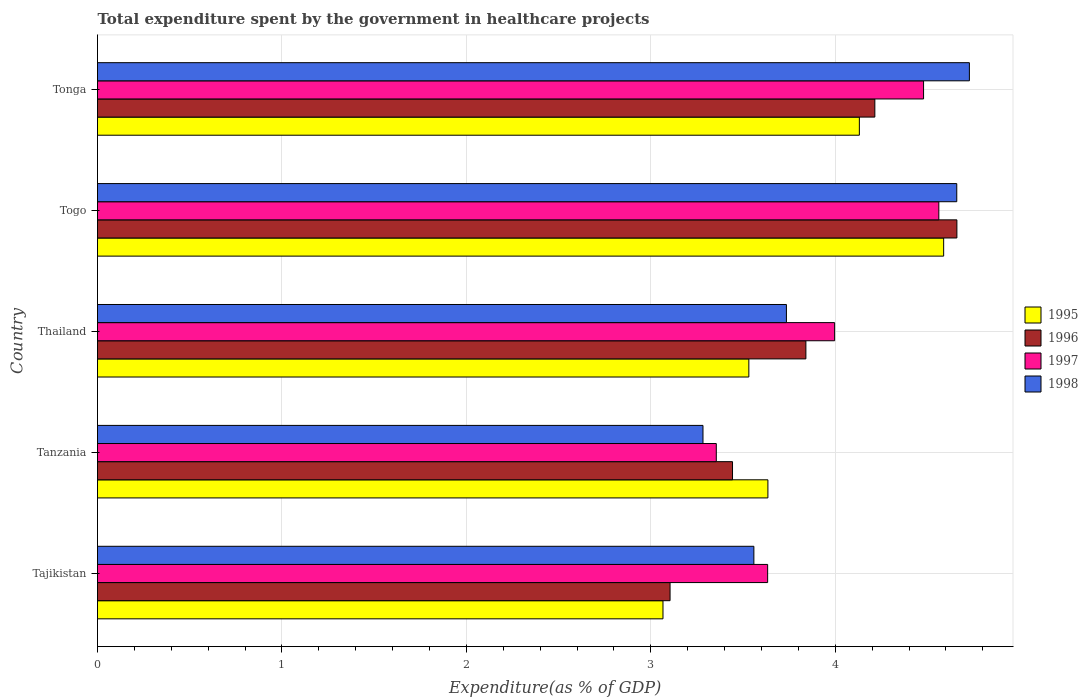How many different coloured bars are there?
Ensure brevity in your answer.  4. Are the number of bars per tick equal to the number of legend labels?
Provide a short and direct response. Yes. How many bars are there on the 3rd tick from the bottom?
Your answer should be compact. 4. What is the label of the 2nd group of bars from the top?
Offer a terse response. Togo. In how many cases, is the number of bars for a given country not equal to the number of legend labels?
Provide a succinct answer. 0. What is the total expenditure spent by the government in healthcare projects in 1998 in Thailand?
Ensure brevity in your answer.  3.74. Across all countries, what is the maximum total expenditure spent by the government in healthcare projects in 1995?
Keep it short and to the point. 4.59. Across all countries, what is the minimum total expenditure spent by the government in healthcare projects in 1995?
Provide a short and direct response. 3.07. In which country was the total expenditure spent by the government in healthcare projects in 1998 maximum?
Ensure brevity in your answer.  Tonga. In which country was the total expenditure spent by the government in healthcare projects in 1998 minimum?
Your answer should be compact. Tanzania. What is the total total expenditure spent by the government in healthcare projects in 1998 in the graph?
Make the answer very short. 19.96. What is the difference between the total expenditure spent by the government in healthcare projects in 1995 in Togo and that in Tonga?
Your response must be concise. 0.46. What is the difference between the total expenditure spent by the government in healthcare projects in 1996 in Tanzania and the total expenditure spent by the government in healthcare projects in 1997 in Tonga?
Provide a short and direct response. -1.04. What is the average total expenditure spent by the government in healthcare projects in 1997 per country?
Offer a very short reply. 4.01. What is the difference between the total expenditure spent by the government in healthcare projects in 1997 and total expenditure spent by the government in healthcare projects in 1998 in Tonga?
Your response must be concise. -0.25. What is the ratio of the total expenditure spent by the government in healthcare projects in 1995 in Tajikistan to that in Tonga?
Your answer should be compact. 0.74. Is the difference between the total expenditure spent by the government in healthcare projects in 1997 in Tanzania and Thailand greater than the difference between the total expenditure spent by the government in healthcare projects in 1998 in Tanzania and Thailand?
Provide a succinct answer. No. What is the difference between the highest and the second highest total expenditure spent by the government in healthcare projects in 1998?
Your answer should be very brief. 0.07. What is the difference between the highest and the lowest total expenditure spent by the government in healthcare projects in 1997?
Your response must be concise. 1.21. What does the 1st bar from the top in Tanzania represents?
Offer a very short reply. 1998. Are all the bars in the graph horizontal?
Your response must be concise. Yes. How many countries are there in the graph?
Offer a terse response. 5. What is the difference between two consecutive major ticks on the X-axis?
Give a very brief answer. 1. Are the values on the major ticks of X-axis written in scientific E-notation?
Provide a short and direct response. No. Does the graph contain any zero values?
Your response must be concise. No. Does the graph contain grids?
Your answer should be very brief. Yes. How are the legend labels stacked?
Your answer should be very brief. Vertical. What is the title of the graph?
Offer a terse response. Total expenditure spent by the government in healthcare projects. Does "1991" appear as one of the legend labels in the graph?
Provide a short and direct response. No. What is the label or title of the X-axis?
Keep it short and to the point. Expenditure(as % of GDP). What is the label or title of the Y-axis?
Your answer should be compact. Country. What is the Expenditure(as % of GDP) in 1995 in Tajikistan?
Offer a terse response. 3.07. What is the Expenditure(as % of GDP) in 1996 in Tajikistan?
Ensure brevity in your answer.  3.1. What is the Expenditure(as % of GDP) of 1997 in Tajikistan?
Your response must be concise. 3.63. What is the Expenditure(as % of GDP) in 1998 in Tajikistan?
Offer a terse response. 3.56. What is the Expenditure(as % of GDP) of 1995 in Tanzania?
Make the answer very short. 3.63. What is the Expenditure(as % of GDP) of 1996 in Tanzania?
Offer a terse response. 3.44. What is the Expenditure(as % of GDP) in 1997 in Tanzania?
Offer a terse response. 3.36. What is the Expenditure(as % of GDP) in 1998 in Tanzania?
Ensure brevity in your answer.  3.28. What is the Expenditure(as % of GDP) in 1995 in Thailand?
Offer a terse response. 3.53. What is the Expenditure(as % of GDP) in 1996 in Thailand?
Give a very brief answer. 3.84. What is the Expenditure(as % of GDP) of 1997 in Thailand?
Ensure brevity in your answer.  4. What is the Expenditure(as % of GDP) of 1998 in Thailand?
Give a very brief answer. 3.74. What is the Expenditure(as % of GDP) in 1995 in Togo?
Your response must be concise. 4.59. What is the Expenditure(as % of GDP) in 1996 in Togo?
Offer a terse response. 4.66. What is the Expenditure(as % of GDP) of 1997 in Togo?
Provide a succinct answer. 4.56. What is the Expenditure(as % of GDP) in 1998 in Togo?
Make the answer very short. 4.66. What is the Expenditure(as % of GDP) in 1995 in Tonga?
Make the answer very short. 4.13. What is the Expenditure(as % of GDP) of 1996 in Tonga?
Your answer should be compact. 4.21. What is the Expenditure(as % of GDP) in 1997 in Tonga?
Keep it short and to the point. 4.48. What is the Expenditure(as % of GDP) of 1998 in Tonga?
Offer a terse response. 4.73. Across all countries, what is the maximum Expenditure(as % of GDP) of 1995?
Give a very brief answer. 4.59. Across all countries, what is the maximum Expenditure(as % of GDP) in 1996?
Ensure brevity in your answer.  4.66. Across all countries, what is the maximum Expenditure(as % of GDP) in 1997?
Ensure brevity in your answer.  4.56. Across all countries, what is the maximum Expenditure(as % of GDP) in 1998?
Your response must be concise. 4.73. Across all countries, what is the minimum Expenditure(as % of GDP) in 1995?
Make the answer very short. 3.07. Across all countries, what is the minimum Expenditure(as % of GDP) in 1996?
Make the answer very short. 3.1. Across all countries, what is the minimum Expenditure(as % of GDP) in 1997?
Offer a very short reply. 3.36. Across all countries, what is the minimum Expenditure(as % of GDP) in 1998?
Keep it short and to the point. 3.28. What is the total Expenditure(as % of GDP) in 1995 in the graph?
Offer a terse response. 18.95. What is the total Expenditure(as % of GDP) of 1996 in the graph?
Your response must be concise. 19.26. What is the total Expenditure(as % of GDP) in 1997 in the graph?
Your response must be concise. 20.03. What is the total Expenditure(as % of GDP) in 1998 in the graph?
Ensure brevity in your answer.  19.96. What is the difference between the Expenditure(as % of GDP) of 1995 in Tajikistan and that in Tanzania?
Offer a very short reply. -0.57. What is the difference between the Expenditure(as % of GDP) of 1996 in Tajikistan and that in Tanzania?
Your answer should be compact. -0.34. What is the difference between the Expenditure(as % of GDP) of 1997 in Tajikistan and that in Tanzania?
Provide a short and direct response. 0.28. What is the difference between the Expenditure(as % of GDP) of 1998 in Tajikistan and that in Tanzania?
Offer a very short reply. 0.28. What is the difference between the Expenditure(as % of GDP) of 1995 in Tajikistan and that in Thailand?
Ensure brevity in your answer.  -0.47. What is the difference between the Expenditure(as % of GDP) in 1996 in Tajikistan and that in Thailand?
Provide a short and direct response. -0.74. What is the difference between the Expenditure(as % of GDP) in 1997 in Tajikistan and that in Thailand?
Your answer should be compact. -0.36. What is the difference between the Expenditure(as % of GDP) in 1998 in Tajikistan and that in Thailand?
Offer a terse response. -0.18. What is the difference between the Expenditure(as % of GDP) in 1995 in Tajikistan and that in Togo?
Offer a terse response. -1.52. What is the difference between the Expenditure(as % of GDP) in 1996 in Tajikistan and that in Togo?
Provide a short and direct response. -1.56. What is the difference between the Expenditure(as % of GDP) of 1997 in Tajikistan and that in Togo?
Offer a very short reply. -0.93. What is the difference between the Expenditure(as % of GDP) of 1998 in Tajikistan and that in Togo?
Provide a short and direct response. -1.1. What is the difference between the Expenditure(as % of GDP) of 1995 in Tajikistan and that in Tonga?
Your answer should be compact. -1.06. What is the difference between the Expenditure(as % of GDP) in 1996 in Tajikistan and that in Tonga?
Give a very brief answer. -1.11. What is the difference between the Expenditure(as % of GDP) in 1997 in Tajikistan and that in Tonga?
Keep it short and to the point. -0.85. What is the difference between the Expenditure(as % of GDP) of 1998 in Tajikistan and that in Tonga?
Keep it short and to the point. -1.17. What is the difference between the Expenditure(as % of GDP) of 1995 in Tanzania and that in Thailand?
Ensure brevity in your answer.  0.1. What is the difference between the Expenditure(as % of GDP) of 1996 in Tanzania and that in Thailand?
Your answer should be very brief. -0.4. What is the difference between the Expenditure(as % of GDP) in 1997 in Tanzania and that in Thailand?
Make the answer very short. -0.64. What is the difference between the Expenditure(as % of GDP) of 1998 in Tanzania and that in Thailand?
Provide a short and direct response. -0.45. What is the difference between the Expenditure(as % of GDP) in 1995 in Tanzania and that in Togo?
Provide a short and direct response. -0.95. What is the difference between the Expenditure(as % of GDP) of 1996 in Tanzania and that in Togo?
Your response must be concise. -1.22. What is the difference between the Expenditure(as % of GDP) of 1997 in Tanzania and that in Togo?
Offer a terse response. -1.21. What is the difference between the Expenditure(as % of GDP) of 1998 in Tanzania and that in Togo?
Your answer should be very brief. -1.38. What is the difference between the Expenditure(as % of GDP) of 1995 in Tanzania and that in Tonga?
Your response must be concise. -0.5. What is the difference between the Expenditure(as % of GDP) in 1996 in Tanzania and that in Tonga?
Your response must be concise. -0.77. What is the difference between the Expenditure(as % of GDP) in 1997 in Tanzania and that in Tonga?
Give a very brief answer. -1.12. What is the difference between the Expenditure(as % of GDP) in 1998 in Tanzania and that in Tonga?
Provide a short and direct response. -1.44. What is the difference between the Expenditure(as % of GDP) in 1995 in Thailand and that in Togo?
Provide a succinct answer. -1.06. What is the difference between the Expenditure(as % of GDP) of 1996 in Thailand and that in Togo?
Your answer should be very brief. -0.82. What is the difference between the Expenditure(as % of GDP) of 1997 in Thailand and that in Togo?
Make the answer very short. -0.56. What is the difference between the Expenditure(as % of GDP) in 1998 in Thailand and that in Togo?
Keep it short and to the point. -0.92. What is the difference between the Expenditure(as % of GDP) in 1995 in Thailand and that in Tonga?
Offer a very short reply. -0.6. What is the difference between the Expenditure(as % of GDP) of 1996 in Thailand and that in Tonga?
Offer a very short reply. -0.37. What is the difference between the Expenditure(as % of GDP) of 1997 in Thailand and that in Tonga?
Your answer should be very brief. -0.48. What is the difference between the Expenditure(as % of GDP) of 1998 in Thailand and that in Tonga?
Offer a terse response. -0.99. What is the difference between the Expenditure(as % of GDP) of 1995 in Togo and that in Tonga?
Make the answer very short. 0.46. What is the difference between the Expenditure(as % of GDP) in 1996 in Togo and that in Tonga?
Offer a terse response. 0.44. What is the difference between the Expenditure(as % of GDP) in 1997 in Togo and that in Tonga?
Your answer should be compact. 0.08. What is the difference between the Expenditure(as % of GDP) in 1998 in Togo and that in Tonga?
Provide a succinct answer. -0.07. What is the difference between the Expenditure(as % of GDP) in 1995 in Tajikistan and the Expenditure(as % of GDP) in 1996 in Tanzania?
Make the answer very short. -0.38. What is the difference between the Expenditure(as % of GDP) of 1995 in Tajikistan and the Expenditure(as % of GDP) of 1997 in Tanzania?
Your answer should be very brief. -0.29. What is the difference between the Expenditure(as % of GDP) of 1995 in Tajikistan and the Expenditure(as % of GDP) of 1998 in Tanzania?
Provide a short and direct response. -0.22. What is the difference between the Expenditure(as % of GDP) of 1996 in Tajikistan and the Expenditure(as % of GDP) of 1997 in Tanzania?
Give a very brief answer. -0.25. What is the difference between the Expenditure(as % of GDP) of 1996 in Tajikistan and the Expenditure(as % of GDP) of 1998 in Tanzania?
Provide a short and direct response. -0.18. What is the difference between the Expenditure(as % of GDP) of 1997 in Tajikistan and the Expenditure(as % of GDP) of 1998 in Tanzania?
Offer a very short reply. 0.35. What is the difference between the Expenditure(as % of GDP) of 1995 in Tajikistan and the Expenditure(as % of GDP) of 1996 in Thailand?
Your answer should be very brief. -0.77. What is the difference between the Expenditure(as % of GDP) of 1995 in Tajikistan and the Expenditure(as % of GDP) of 1997 in Thailand?
Provide a short and direct response. -0.93. What is the difference between the Expenditure(as % of GDP) of 1995 in Tajikistan and the Expenditure(as % of GDP) of 1998 in Thailand?
Ensure brevity in your answer.  -0.67. What is the difference between the Expenditure(as % of GDP) in 1996 in Tajikistan and the Expenditure(as % of GDP) in 1997 in Thailand?
Offer a very short reply. -0.89. What is the difference between the Expenditure(as % of GDP) in 1996 in Tajikistan and the Expenditure(as % of GDP) in 1998 in Thailand?
Your response must be concise. -0.63. What is the difference between the Expenditure(as % of GDP) of 1997 in Tajikistan and the Expenditure(as % of GDP) of 1998 in Thailand?
Give a very brief answer. -0.1. What is the difference between the Expenditure(as % of GDP) of 1995 in Tajikistan and the Expenditure(as % of GDP) of 1996 in Togo?
Provide a succinct answer. -1.59. What is the difference between the Expenditure(as % of GDP) of 1995 in Tajikistan and the Expenditure(as % of GDP) of 1997 in Togo?
Provide a short and direct response. -1.5. What is the difference between the Expenditure(as % of GDP) of 1995 in Tajikistan and the Expenditure(as % of GDP) of 1998 in Togo?
Offer a very short reply. -1.59. What is the difference between the Expenditure(as % of GDP) of 1996 in Tajikistan and the Expenditure(as % of GDP) of 1997 in Togo?
Ensure brevity in your answer.  -1.46. What is the difference between the Expenditure(as % of GDP) in 1996 in Tajikistan and the Expenditure(as % of GDP) in 1998 in Togo?
Your answer should be compact. -1.55. What is the difference between the Expenditure(as % of GDP) in 1997 in Tajikistan and the Expenditure(as % of GDP) in 1998 in Togo?
Ensure brevity in your answer.  -1.03. What is the difference between the Expenditure(as % of GDP) of 1995 in Tajikistan and the Expenditure(as % of GDP) of 1996 in Tonga?
Your answer should be very brief. -1.15. What is the difference between the Expenditure(as % of GDP) of 1995 in Tajikistan and the Expenditure(as % of GDP) of 1997 in Tonga?
Your answer should be very brief. -1.41. What is the difference between the Expenditure(as % of GDP) of 1995 in Tajikistan and the Expenditure(as % of GDP) of 1998 in Tonga?
Keep it short and to the point. -1.66. What is the difference between the Expenditure(as % of GDP) in 1996 in Tajikistan and the Expenditure(as % of GDP) in 1997 in Tonga?
Your answer should be compact. -1.37. What is the difference between the Expenditure(as % of GDP) of 1996 in Tajikistan and the Expenditure(as % of GDP) of 1998 in Tonga?
Your answer should be compact. -1.62. What is the difference between the Expenditure(as % of GDP) in 1997 in Tajikistan and the Expenditure(as % of GDP) in 1998 in Tonga?
Offer a very short reply. -1.09. What is the difference between the Expenditure(as % of GDP) in 1995 in Tanzania and the Expenditure(as % of GDP) in 1996 in Thailand?
Provide a succinct answer. -0.21. What is the difference between the Expenditure(as % of GDP) of 1995 in Tanzania and the Expenditure(as % of GDP) of 1997 in Thailand?
Provide a succinct answer. -0.36. What is the difference between the Expenditure(as % of GDP) in 1995 in Tanzania and the Expenditure(as % of GDP) in 1998 in Thailand?
Offer a very short reply. -0.1. What is the difference between the Expenditure(as % of GDP) in 1996 in Tanzania and the Expenditure(as % of GDP) in 1997 in Thailand?
Keep it short and to the point. -0.55. What is the difference between the Expenditure(as % of GDP) of 1996 in Tanzania and the Expenditure(as % of GDP) of 1998 in Thailand?
Keep it short and to the point. -0.29. What is the difference between the Expenditure(as % of GDP) in 1997 in Tanzania and the Expenditure(as % of GDP) in 1998 in Thailand?
Your answer should be compact. -0.38. What is the difference between the Expenditure(as % of GDP) of 1995 in Tanzania and the Expenditure(as % of GDP) of 1996 in Togo?
Keep it short and to the point. -1.02. What is the difference between the Expenditure(as % of GDP) of 1995 in Tanzania and the Expenditure(as % of GDP) of 1997 in Togo?
Keep it short and to the point. -0.93. What is the difference between the Expenditure(as % of GDP) of 1995 in Tanzania and the Expenditure(as % of GDP) of 1998 in Togo?
Your answer should be compact. -1.02. What is the difference between the Expenditure(as % of GDP) of 1996 in Tanzania and the Expenditure(as % of GDP) of 1997 in Togo?
Give a very brief answer. -1.12. What is the difference between the Expenditure(as % of GDP) in 1996 in Tanzania and the Expenditure(as % of GDP) in 1998 in Togo?
Keep it short and to the point. -1.22. What is the difference between the Expenditure(as % of GDP) of 1997 in Tanzania and the Expenditure(as % of GDP) of 1998 in Togo?
Offer a very short reply. -1.3. What is the difference between the Expenditure(as % of GDP) in 1995 in Tanzania and the Expenditure(as % of GDP) in 1996 in Tonga?
Provide a short and direct response. -0.58. What is the difference between the Expenditure(as % of GDP) of 1995 in Tanzania and the Expenditure(as % of GDP) of 1997 in Tonga?
Make the answer very short. -0.84. What is the difference between the Expenditure(as % of GDP) of 1995 in Tanzania and the Expenditure(as % of GDP) of 1998 in Tonga?
Make the answer very short. -1.09. What is the difference between the Expenditure(as % of GDP) of 1996 in Tanzania and the Expenditure(as % of GDP) of 1997 in Tonga?
Offer a very short reply. -1.04. What is the difference between the Expenditure(as % of GDP) of 1996 in Tanzania and the Expenditure(as % of GDP) of 1998 in Tonga?
Provide a succinct answer. -1.28. What is the difference between the Expenditure(as % of GDP) of 1997 in Tanzania and the Expenditure(as % of GDP) of 1998 in Tonga?
Provide a succinct answer. -1.37. What is the difference between the Expenditure(as % of GDP) of 1995 in Thailand and the Expenditure(as % of GDP) of 1996 in Togo?
Offer a terse response. -1.13. What is the difference between the Expenditure(as % of GDP) of 1995 in Thailand and the Expenditure(as % of GDP) of 1997 in Togo?
Give a very brief answer. -1.03. What is the difference between the Expenditure(as % of GDP) in 1995 in Thailand and the Expenditure(as % of GDP) in 1998 in Togo?
Offer a very short reply. -1.13. What is the difference between the Expenditure(as % of GDP) in 1996 in Thailand and the Expenditure(as % of GDP) in 1997 in Togo?
Your answer should be compact. -0.72. What is the difference between the Expenditure(as % of GDP) in 1996 in Thailand and the Expenditure(as % of GDP) in 1998 in Togo?
Your response must be concise. -0.82. What is the difference between the Expenditure(as % of GDP) of 1997 in Thailand and the Expenditure(as % of GDP) of 1998 in Togo?
Ensure brevity in your answer.  -0.66. What is the difference between the Expenditure(as % of GDP) in 1995 in Thailand and the Expenditure(as % of GDP) in 1996 in Tonga?
Your answer should be compact. -0.68. What is the difference between the Expenditure(as % of GDP) of 1995 in Thailand and the Expenditure(as % of GDP) of 1997 in Tonga?
Your answer should be very brief. -0.95. What is the difference between the Expenditure(as % of GDP) in 1995 in Thailand and the Expenditure(as % of GDP) in 1998 in Tonga?
Make the answer very short. -1.2. What is the difference between the Expenditure(as % of GDP) of 1996 in Thailand and the Expenditure(as % of GDP) of 1997 in Tonga?
Give a very brief answer. -0.64. What is the difference between the Expenditure(as % of GDP) of 1996 in Thailand and the Expenditure(as % of GDP) of 1998 in Tonga?
Ensure brevity in your answer.  -0.89. What is the difference between the Expenditure(as % of GDP) in 1997 in Thailand and the Expenditure(as % of GDP) in 1998 in Tonga?
Offer a very short reply. -0.73. What is the difference between the Expenditure(as % of GDP) of 1995 in Togo and the Expenditure(as % of GDP) of 1996 in Tonga?
Provide a succinct answer. 0.37. What is the difference between the Expenditure(as % of GDP) of 1995 in Togo and the Expenditure(as % of GDP) of 1997 in Tonga?
Keep it short and to the point. 0.11. What is the difference between the Expenditure(as % of GDP) in 1995 in Togo and the Expenditure(as % of GDP) in 1998 in Tonga?
Offer a terse response. -0.14. What is the difference between the Expenditure(as % of GDP) in 1996 in Togo and the Expenditure(as % of GDP) in 1997 in Tonga?
Keep it short and to the point. 0.18. What is the difference between the Expenditure(as % of GDP) of 1996 in Togo and the Expenditure(as % of GDP) of 1998 in Tonga?
Make the answer very short. -0.07. What is the difference between the Expenditure(as % of GDP) in 1997 in Togo and the Expenditure(as % of GDP) in 1998 in Tonga?
Give a very brief answer. -0.17. What is the average Expenditure(as % of GDP) in 1995 per country?
Give a very brief answer. 3.79. What is the average Expenditure(as % of GDP) in 1996 per country?
Your answer should be very brief. 3.85. What is the average Expenditure(as % of GDP) of 1997 per country?
Provide a short and direct response. 4.01. What is the average Expenditure(as % of GDP) in 1998 per country?
Your answer should be very brief. 3.99. What is the difference between the Expenditure(as % of GDP) in 1995 and Expenditure(as % of GDP) in 1996 in Tajikistan?
Your response must be concise. -0.04. What is the difference between the Expenditure(as % of GDP) of 1995 and Expenditure(as % of GDP) of 1997 in Tajikistan?
Offer a very short reply. -0.57. What is the difference between the Expenditure(as % of GDP) of 1995 and Expenditure(as % of GDP) of 1998 in Tajikistan?
Offer a very short reply. -0.49. What is the difference between the Expenditure(as % of GDP) in 1996 and Expenditure(as % of GDP) in 1997 in Tajikistan?
Provide a succinct answer. -0.53. What is the difference between the Expenditure(as % of GDP) in 1996 and Expenditure(as % of GDP) in 1998 in Tajikistan?
Provide a succinct answer. -0.45. What is the difference between the Expenditure(as % of GDP) in 1997 and Expenditure(as % of GDP) in 1998 in Tajikistan?
Provide a short and direct response. 0.07. What is the difference between the Expenditure(as % of GDP) in 1995 and Expenditure(as % of GDP) in 1996 in Tanzania?
Your answer should be very brief. 0.19. What is the difference between the Expenditure(as % of GDP) of 1995 and Expenditure(as % of GDP) of 1997 in Tanzania?
Keep it short and to the point. 0.28. What is the difference between the Expenditure(as % of GDP) in 1995 and Expenditure(as % of GDP) in 1998 in Tanzania?
Keep it short and to the point. 0.35. What is the difference between the Expenditure(as % of GDP) in 1996 and Expenditure(as % of GDP) in 1997 in Tanzania?
Your answer should be compact. 0.09. What is the difference between the Expenditure(as % of GDP) in 1996 and Expenditure(as % of GDP) in 1998 in Tanzania?
Offer a terse response. 0.16. What is the difference between the Expenditure(as % of GDP) of 1997 and Expenditure(as % of GDP) of 1998 in Tanzania?
Provide a short and direct response. 0.07. What is the difference between the Expenditure(as % of GDP) of 1995 and Expenditure(as % of GDP) of 1996 in Thailand?
Your answer should be very brief. -0.31. What is the difference between the Expenditure(as % of GDP) of 1995 and Expenditure(as % of GDP) of 1997 in Thailand?
Make the answer very short. -0.47. What is the difference between the Expenditure(as % of GDP) of 1995 and Expenditure(as % of GDP) of 1998 in Thailand?
Your response must be concise. -0.2. What is the difference between the Expenditure(as % of GDP) of 1996 and Expenditure(as % of GDP) of 1997 in Thailand?
Ensure brevity in your answer.  -0.16. What is the difference between the Expenditure(as % of GDP) of 1996 and Expenditure(as % of GDP) of 1998 in Thailand?
Ensure brevity in your answer.  0.11. What is the difference between the Expenditure(as % of GDP) in 1997 and Expenditure(as % of GDP) in 1998 in Thailand?
Offer a very short reply. 0.26. What is the difference between the Expenditure(as % of GDP) of 1995 and Expenditure(as % of GDP) of 1996 in Togo?
Keep it short and to the point. -0.07. What is the difference between the Expenditure(as % of GDP) of 1995 and Expenditure(as % of GDP) of 1997 in Togo?
Your response must be concise. 0.03. What is the difference between the Expenditure(as % of GDP) in 1995 and Expenditure(as % of GDP) in 1998 in Togo?
Offer a very short reply. -0.07. What is the difference between the Expenditure(as % of GDP) of 1996 and Expenditure(as % of GDP) of 1997 in Togo?
Provide a succinct answer. 0.1. What is the difference between the Expenditure(as % of GDP) in 1996 and Expenditure(as % of GDP) in 1998 in Togo?
Keep it short and to the point. 0. What is the difference between the Expenditure(as % of GDP) of 1997 and Expenditure(as % of GDP) of 1998 in Togo?
Your response must be concise. -0.1. What is the difference between the Expenditure(as % of GDP) of 1995 and Expenditure(as % of GDP) of 1996 in Tonga?
Your response must be concise. -0.08. What is the difference between the Expenditure(as % of GDP) of 1995 and Expenditure(as % of GDP) of 1997 in Tonga?
Your response must be concise. -0.35. What is the difference between the Expenditure(as % of GDP) of 1995 and Expenditure(as % of GDP) of 1998 in Tonga?
Provide a short and direct response. -0.6. What is the difference between the Expenditure(as % of GDP) of 1996 and Expenditure(as % of GDP) of 1997 in Tonga?
Your response must be concise. -0.26. What is the difference between the Expenditure(as % of GDP) in 1996 and Expenditure(as % of GDP) in 1998 in Tonga?
Offer a terse response. -0.51. What is the difference between the Expenditure(as % of GDP) of 1997 and Expenditure(as % of GDP) of 1998 in Tonga?
Provide a succinct answer. -0.25. What is the ratio of the Expenditure(as % of GDP) in 1995 in Tajikistan to that in Tanzania?
Offer a terse response. 0.84. What is the ratio of the Expenditure(as % of GDP) of 1996 in Tajikistan to that in Tanzania?
Keep it short and to the point. 0.9. What is the ratio of the Expenditure(as % of GDP) of 1997 in Tajikistan to that in Tanzania?
Your response must be concise. 1.08. What is the ratio of the Expenditure(as % of GDP) of 1998 in Tajikistan to that in Tanzania?
Your response must be concise. 1.08. What is the ratio of the Expenditure(as % of GDP) in 1995 in Tajikistan to that in Thailand?
Your answer should be very brief. 0.87. What is the ratio of the Expenditure(as % of GDP) of 1996 in Tajikistan to that in Thailand?
Make the answer very short. 0.81. What is the ratio of the Expenditure(as % of GDP) in 1998 in Tajikistan to that in Thailand?
Make the answer very short. 0.95. What is the ratio of the Expenditure(as % of GDP) of 1995 in Tajikistan to that in Togo?
Provide a succinct answer. 0.67. What is the ratio of the Expenditure(as % of GDP) in 1996 in Tajikistan to that in Togo?
Make the answer very short. 0.67. What is the ratio of the Expenditure(as % of GDP) of 1997 in Tajikistan to that in Togo?
Offer a terse response. 0.8. What is the ratio of the Expenditure(as % of GDP) of 1998 in Tajikistan to that in Togo?
Your response must be concise. 0.76. What is the ratio of the Expenditure(as % of GDP) of 1995 in Tajikistan to that in Tonga?
Your answer should be very brief. 0.74. What is the ratio of the Expenditure(as % of GDP) in 1996 in Tajikistan to that in Tonga?
Give a very brief answer. 0.74. What is the ratio of the Expenditure(as % of GDP) in 1997 in Tajikistan to that in Tonga?
Provide a short and direct response. 0.81. What is the ratio of the Expenditure(as % of GDP) in 1998 in Tajikistan to that in Tonga?
Ensure brevity in your answer.  0.75. What is the ratio of the Expenditure(as % of GDP) in 1995 in Tanzania to that in Thailand?
Offer a very short reply. 1.03. What is the ratio of the Expenditure(as % of GDP) in 1996 in Tanzania to that in Thailand?
Make the answer very short. 0.9. What is the ratio of the Expenditure(as % of GDP) of 1997 in Tanzania to that in Thailand?
Offer a very short reply. 0.84. What is the ratio of the Expenditure(as % of GDP) in 1998 in Tanzania to that in Thailand?
Provide a short and direct response. 0.88. What is the ratio of the Expenditure(as % of GDP) of 1995 in Tanzania to that in Togo?
Provide a short and direct response. 0.79. What is the ratio of the Expenditure(as % of GDP) of 1996 in Tanzania to that in Togo?
Provide a succinct answer. 0.74. What is the ratio of the Expenditure(as % of GDP) of 1997 in Tanzania to that in Togo?
Offer a very short reply. 0.74. What is the ratio of the Expenditure(as % of GDP) of 1998 in Tanzania to that in Togo?
Offer a terse response. 0.7. What is the ratio of the Expenditure(as % of GDP) of 1995 in Tanzania to that in Tonga?
Give a very brief answer. 0.88. What is the ratio of the Expenditure(as % of GDP) of 1996 in Tanzania to that in Tonga?
Ensure brevity in your answer.  0.82. What is the ratio of the Expenditure(as % of GDP) of 1997 in Tanzania to that in Tonga?
Provide a short and direct response. 0.75. What is the ratio of the Expenditure(as % of GDP) in 1998 in Tanzania to that in Tonga?
Provide a succinct answer. 0.69. What is the ratio of the Expenditure(as % of GDP) in 1995 in Thailand to that in Togo?
Ensure brevity in your answer.  0.77. What is the ratio of the Expenditure(as % of GDP) of 1996 in Thailand to that in Togo?
Provide a succinct answer. 0.82. What is the ratio of the Expenditure(as % of GDP) of 1997 in Thailand to that in Togo?
Ensure brevity in your answer.  0.88. What is the ratio of the Expenditure(as % of GDP) of 1998 in Thailand to that in Togo?
Ensure brevity in your answer.  0.8. What is the ratio of the Expenditure(as % of GDP) of 1995 in Thailand to that in Tonga?
Your answer should be very brief. 0.85. What is the ratio of the Expenditure(as % of GDP) in 1996 in Thailand to that in Tonga?
Offer a terse response. 0.91. What is the ratio of the Expenditure(as % of GDP) in 1997 in Thailand to that in Tonga?
Your answer should be very brief. 0.89. What is the ratio of the Expenditure(as % of GDP) of 1998 in Thailand to that in Tonga?
Keep it short and to the point. 0.79. What is the ratio of the Expenditure(as % of GDP) in 1995 in Togo to that in Tonga?
Give a very brief answer. 1.11. What is the ratio of the Expenditure(as % of GDP) in 1996 in Togo to that in Tonga?
Ensure brevity in your answer.  1.11. What is the ratio of the Expenditure(as % of GDP) of 1997 in Togo to that in Tonga?
Provide a succinct answer. 1.02. What is the ratio of the Expenditure(as % of GDP) in 1998 in Togo to that in Tonga?
Give a very brief answer. 0.99. What is the difference between the highest and the second highest Expenditure(as % of GDP) in 1995?
Your response must be concise. 0.46. What is the difference between the highest and the second highest Expenditure(as % of GDP) in 1996?
Your answer should be very brief. 0.44. What is the difference between the highest and the second highest Expenditure(as % of GDP) in 1997?
Ensure brevity in your answer.  0.08. What is the difference between the highest and the second highest Expenditure(as % of GDP) in 1998?
Offer a terse response. 0.07. What is the difference between the highest and the lowest Expenditure(as % of GDP) of 1995?
Offer a very short reply. 1.52. What is the difference between the highest and the lowest Expenditure(as % of GDP) of 1996?
Make the answer very short. 1.56. What is the difference between the highest and the lowest Expenditure(as % of GDP) in 1997?
Offer a terse response. 1.21. What is the difference between the highest and the lowest Expenditure(as % of GDP) in 1998?
Your response must be concise. 1.44. 